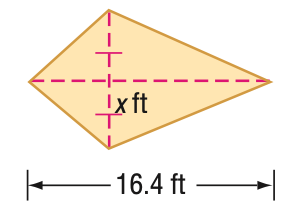Question: Find x. A = 104 ft^2.
Choices:
A. 6.3
B. 6.5
C. 7.4
D. 13.0
Answer with the letter. Answer: A 